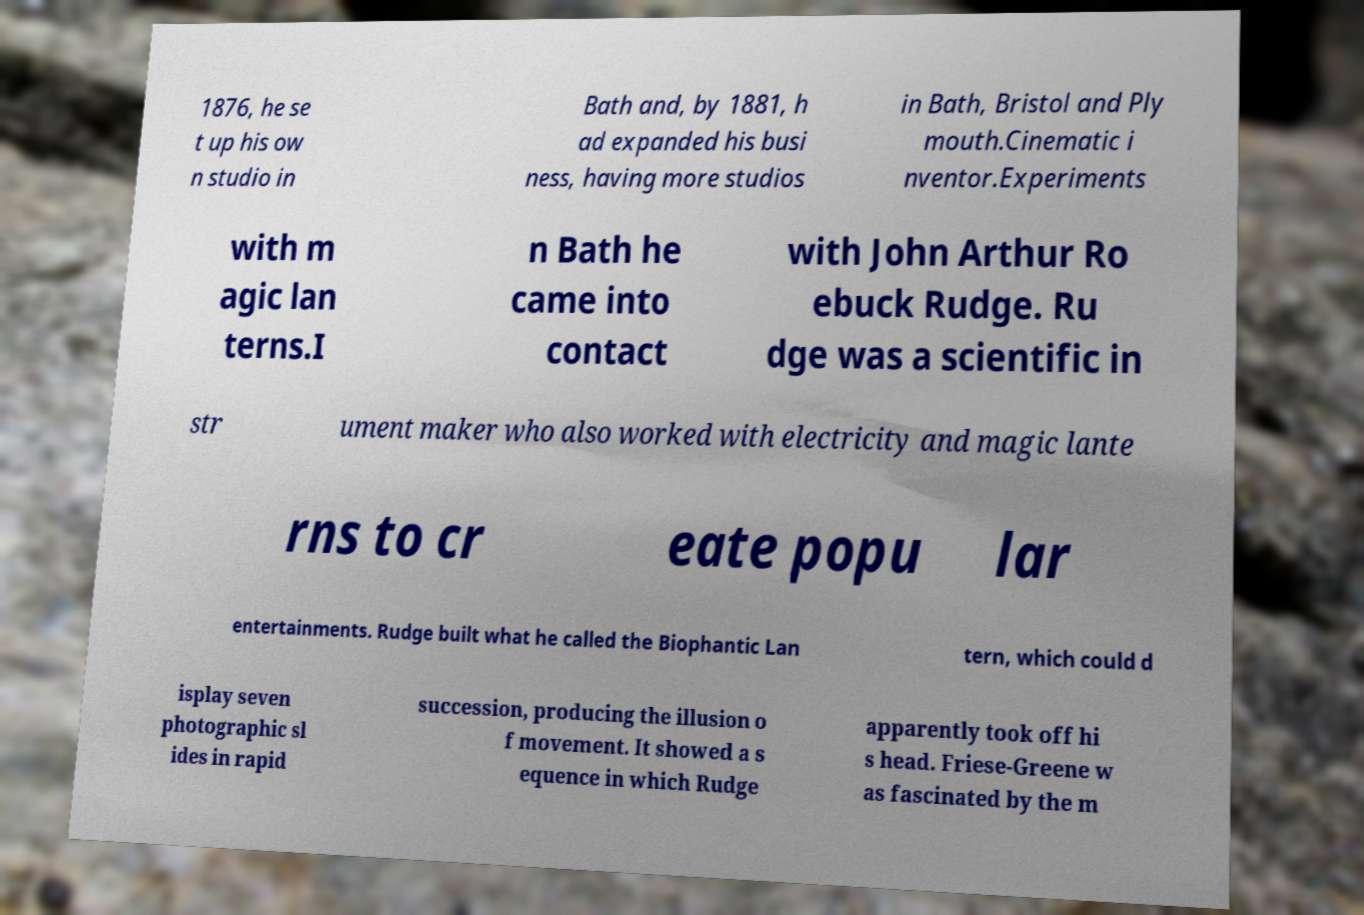There's text embedded in this image that I need extracted. Can you transcribe it verbatim? 1876, he se t up his ow n studio in Bath and, by 1881, h ad expanded his busi ness, having more studios in Bath, Bristol and Ply mouth.Cinematic i nventor.Experiments with m agic lan terns.I n Bath he came into contact with John Arthur Ro ebuck Rudge. Ru dge was a scientific in str ument maker who also worked with electricity and magic lante rns to cr eate popu lar entertainments. Rudge built what he called the Biophantic Lan tern, which could d isplay seven photographic sl ides in rapid succession, producing the illusion o f movement. It showed a s equence in which Rudge apparently took off hi s head. Friese-Greene w as fascinated by the m 